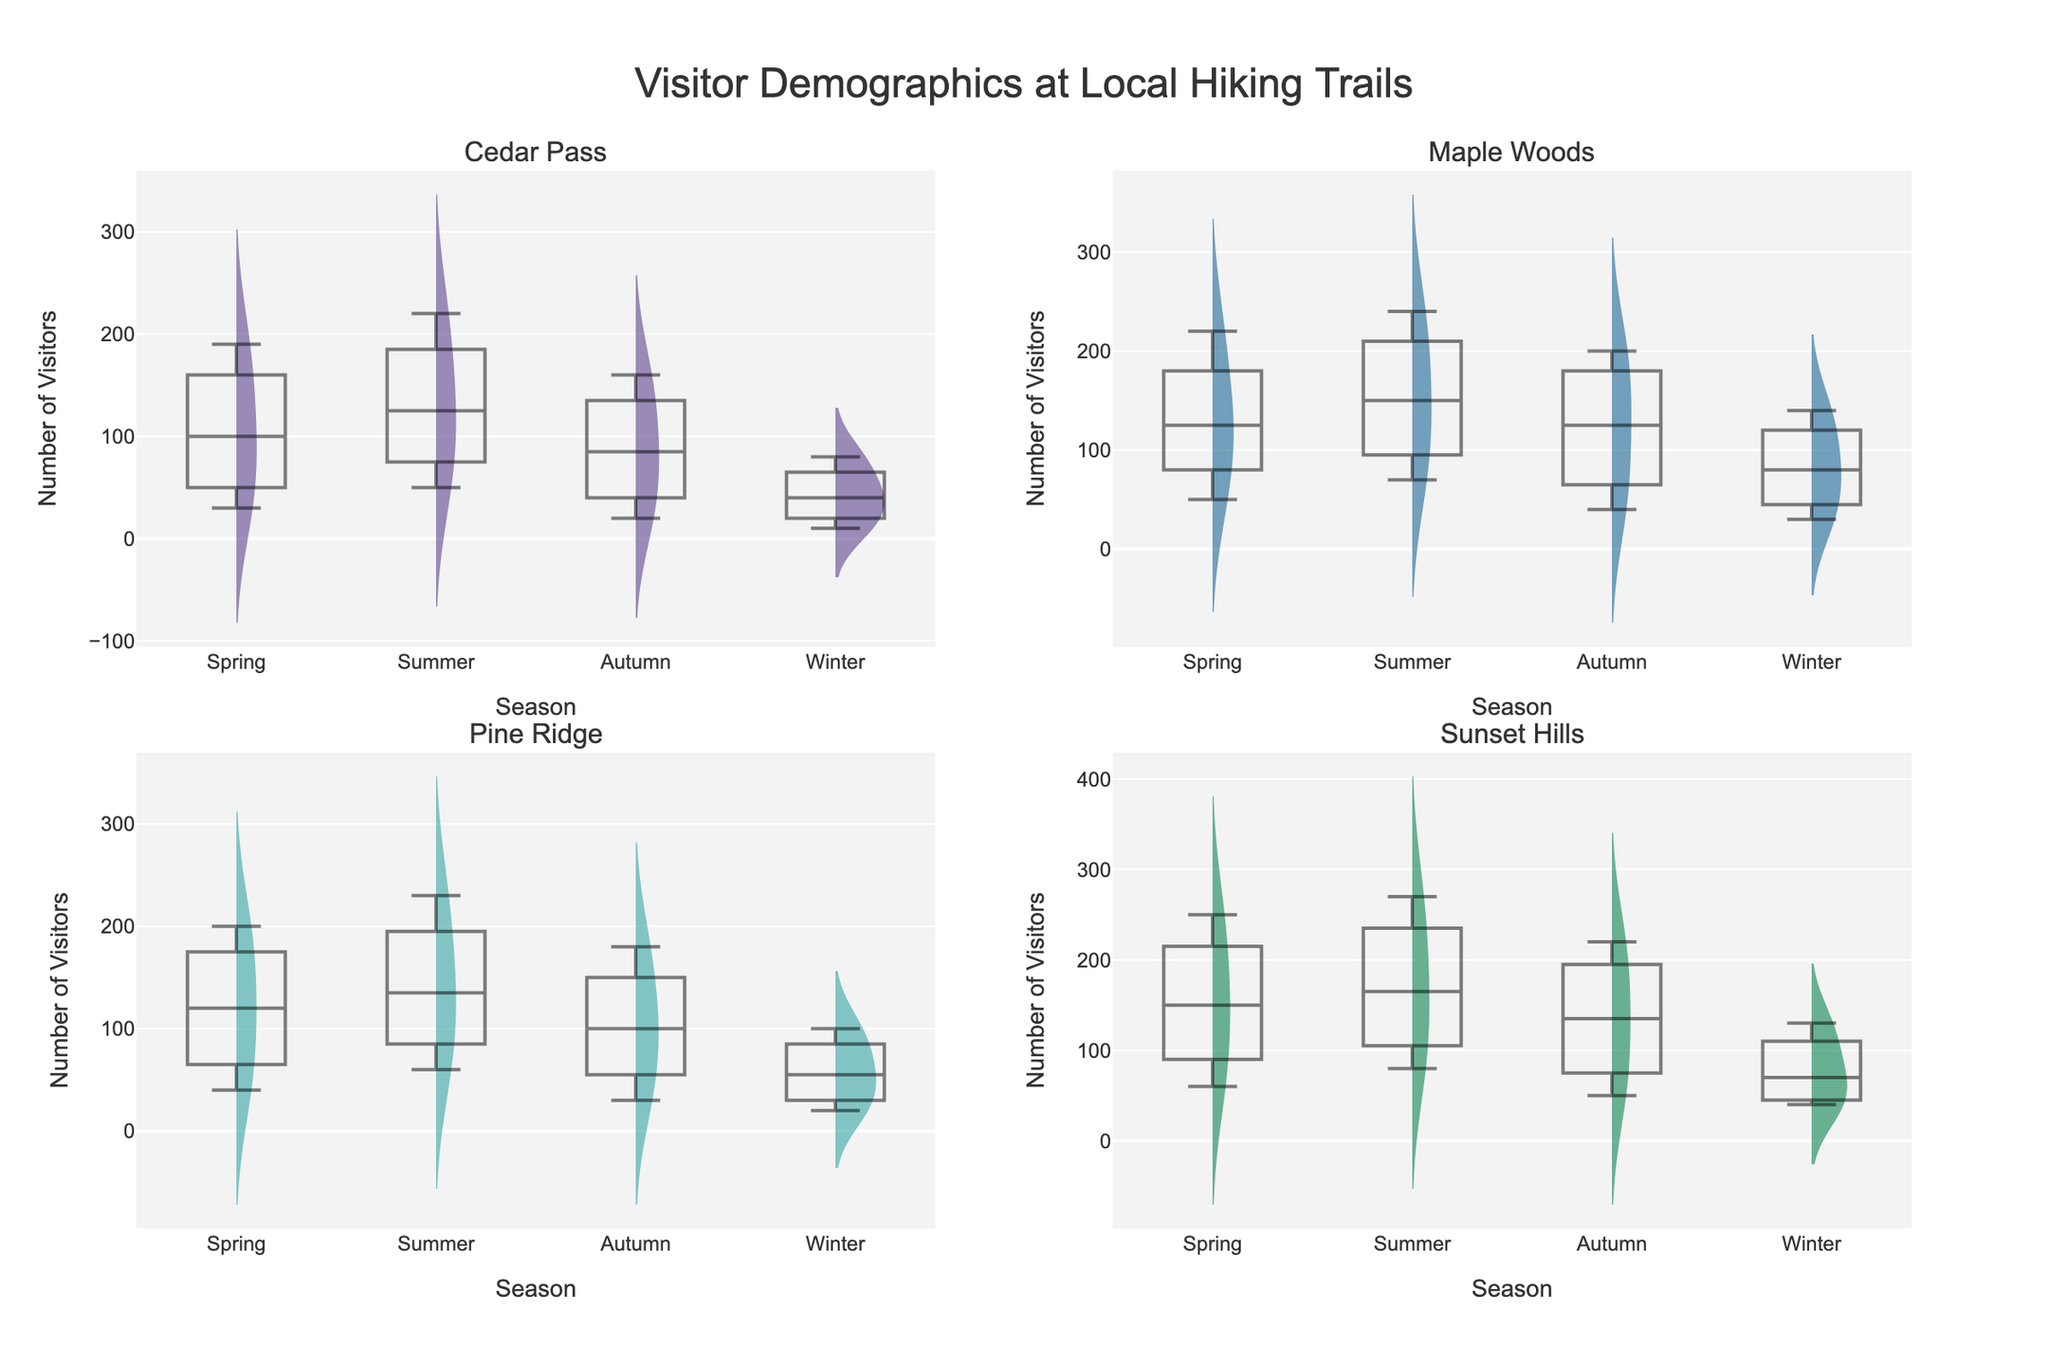How many unique trails are depicted in the figure? The title of each subplot represents a unique trail. By observing the subplot titles, we see there are four different trails: Sunset Hills, Pine Ridge, Maple Woods, and Cedar Pass.
Answer: 4 Which trail has the highest number of visitors during the summer? By comparing the highest points in the violin and box plots for each trail during the summer, we observe that Sunset Hills has the highest peak in visitors during the summer.
Answer: Sunset Hills Which age group appears to have the least variability in the number of visitors across all seasons and trails? Observing the box plots for each age group across all trails and seasons, the "Under 18" age group shows the least variability with smaller spread in the boxplots.
Answer: Under 18 What's the median number of visitors for Pine Ridge in Autumn across all age groups? The median number is marked by the line inside the box in the box plot. For Pine Ridge in Autumn, the box plot's medians for each age group are: Under 18: 80, 18-30: 180, 31-50: 120, 51+: 30. To calculate the overall median, list all visitor numbers: 80, 180, 120, 30. The middle two numbers are 80 and 120, so the median is (80+120)/2 = 100.
Answer: 100 In which season does Cedar Pass have the lowest number of visitors across all age groups? By observing the box plots, the lowest points overall for Cedar Pass across all seasons and age groups occur in Winter.
Answer: Winter Which trail shows the biggest change in visitor numbers from Spring to Winter? By comparing the box plots for each trail from Spring to Winter, we see Cedar Pass has the biggest drop in visitor numbers from higher values in Spring to significantly lower values in Winter.
Answer: Cedar Pass What season has the highest number of visitors for the 18-30 age group on average across all trails? From observing the box plots for the 18-30 age group across all trails, we calculate the highest medians: Spring: 220, Summer: 240, Autumn: 220, Winter: 140. Summer has the highest average.
Answer: Summer Which trail and season combination has the lowest number of visitors for the 51+ age group? By looking for the lowest points in the box plots for the 51+ age group across all trails and seasons, we find the lowest number is at Cedar Pass in Winter.
Answer: Cedar Pass, Winter Which two age groups have the closest median number of visitors during Summer at Maple Woods? By comparing the box plot medians in Summer for Maple Woods, the medians for the age groups are: Under 18: 120, 18-30: 240, 31-50: 180, 51+: 70. The closest medians are for the Under 18 (120) and 51+ (70) age groups, but the closest in value are more likely the Under 18 (120) and 31-50 (180) with a difference of 60.
Answer: Under 18 and 31-50 